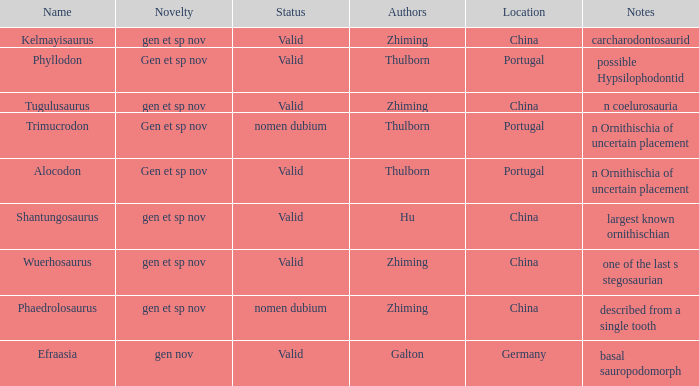What is the Name of the dinosaur, whose notes are, "n ornithischia of uncertain placement"? Alocodon, Trimucrodon. 